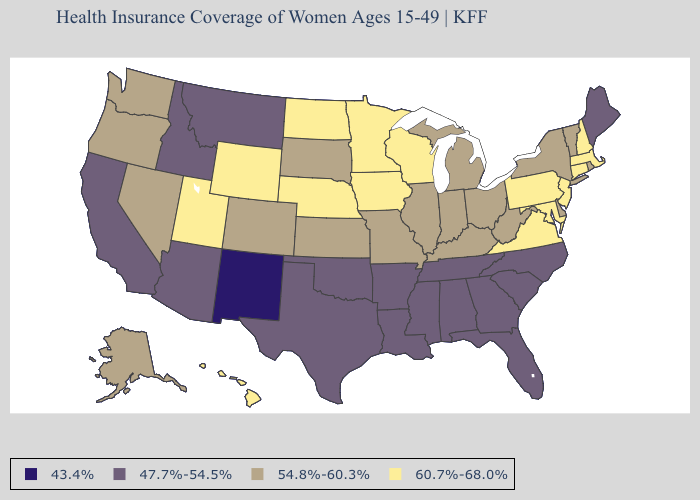What is the value of Hawaii?
Short answer required. 60.7%-68.0%. What is the lowest value in the South?
Short answer required. 47.7%-54.5%. Among the states that border Missouri , does Tennessee have the lowest value?
Quick response, please. Yes. Is the legend a continuous bar?
Concise answer only. No. Does Massachusetts have the highest value in the USA?
Keep it brief. Yes. What is the highest value in states that border Georgia?
Concise answer only. 47.7%-54.5%. Which states have the lowest value in the South?
Quick response, please. Alabama, Arkansas, Florida, Georgia, Louisiana, Mississippi, North Carolina, Oklahoma, South Carolina, Tennessee, Texas. Does the map have missing data?
Be succinct. No. Among the states that border Idaho , does Wyoming have the highest value?
Write a very short answer. Yes. Which states have the lowest value in the USA?
Be succinct. New Mexico. Does South Dakota have the lowest value in the MidWest?
Give a very brief answer. Yes. Among the states that border Illinois , does Indiana have the lowest value?
Short answer required. Yes. Which states have the highest value in the USA?
Short answer required. Connecticut, Hawaii, Iowa, Maryland, Massachusetts, Minnesota, Nebraska, New Hampshire, New Jersey, North Dakota, Pennsylvania, Utah, Virginia, Wisconsin, Wyoming. Among the states that border Ohio , which have the highest value?
Be succinct. Pennsylvania. What is the lowest value in the West?
Give a very brief answer. 43.4%. 